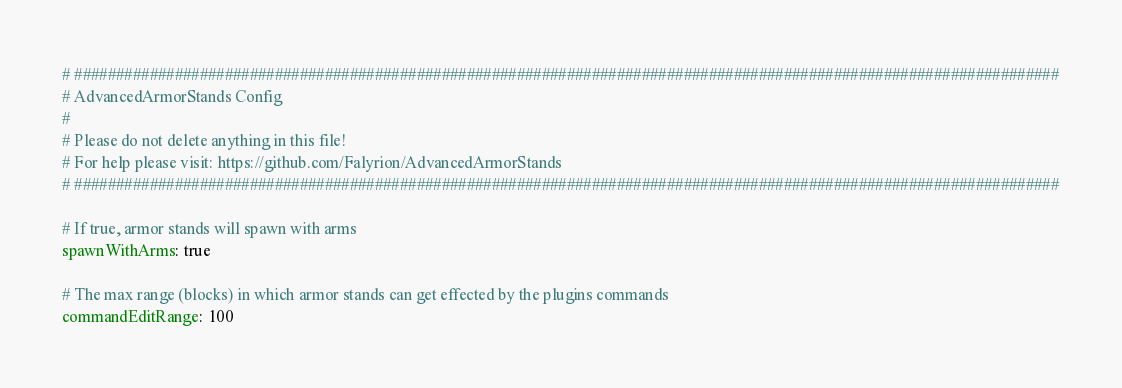Convert code to text. <code><loc_0><loc_0><loc_500><loc_500><_YAML_># ######################################################################################################################
# AdvancedArmorStands Config
#
# Please do not delete anything in this file!
# For help please visit: https://github.com/Falyrion/AdvancedArmorStands
# ######################################################################################################################

# If true, armor stands will spawn with arms
spawnWithArms: true

# The max range (blocks) in which armor stands can get effected by the plugins commands
commandEditRange: 100
</code> 